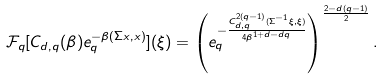<formula> <loc_0><loc_0><loc_500><loc_500>\mathcal { F } _ { q } [ C _ { d , q } ( \beta ) e _ { q } ^ { - \beta ( \Sigma x , x ) } ] ( \xi ) = \left ( e _ { q } ^ { - \frac { C _ { d , q } ^ { 2 ( q - 1 ) } ( \Sigma ^ { - 1 } \xi , \xi ) } { 4 \beta ^ { 1 + d - d q } } } \right ) ^ { \frac { 2 - d ( q - 1 ) } { 2 } } .</formula> 